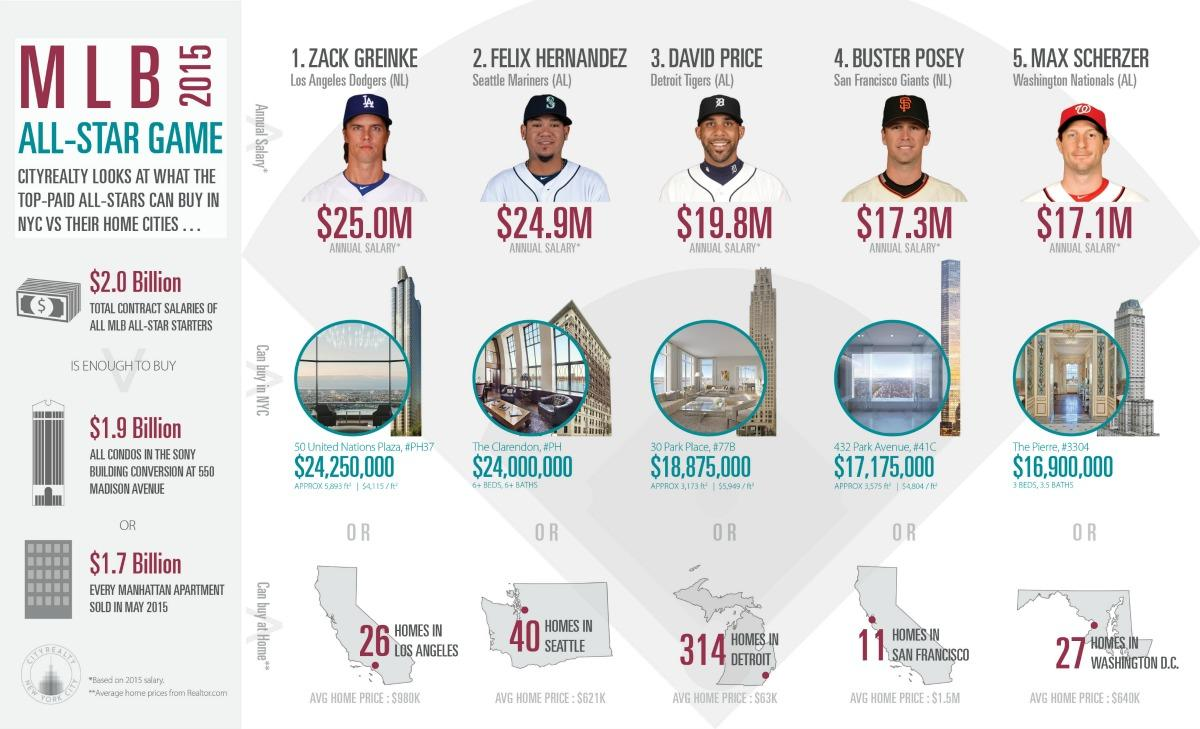Indicate a few pertinent items in this graphic. The total salary amount for David Price and Buster Posey, taken together, is 37.1 million dollars. David Price's annual salary is approximately $19.8 million. The area of 432 Park Avenue is approximately 3,575 square feet. Felix Hernandez, one of the players, has the second-highest salary among his peers. The average price of a home in Seattle is $621,000. 